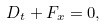<formula> <loc_0><loc_0><loc_500><loc_500>D _ { t } + F _ { x } = 0 ,</formula> 